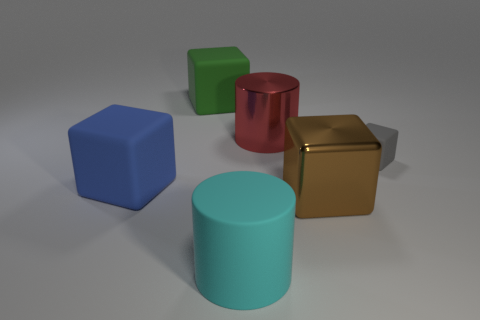What number of blocks are big cyan objects or small matte things?
Give a very brief answer. 1. The big shiny object in front of the rubber cube that is right of the big cyan cylinder is what color?
Offer a very short reply. Brown. There is a small thing; is it the same color as the large rubber object that is behind the gray matte thing?
Your response must be concise. No. The other thing that is made of the same material as the red thing is what size?
Keep it short and to the point. Large. Is the color of the metal block the same as the big shiny cylinder?
Offer a terse response. No. There is a cylinder in front of the rubber cube left of the green cube; are there any big blue matte objects that are in front of it?
Your response must be concise. No. How many brown shiny cubes are the same size as the brown object?
Your response must be concise. 0. Does the gray matte block that is in front of the large metallic cylinder have the same size as the cube behind the metal cylinder?
Your answer should be very brief. No. There is a rubber object that is both on the right side of the green rubber block and in front of the gray rubber object; what is its shape?
Your answer should be compact. Cylinder. Is there a large rubber object of the same color as the metal cube?
Provide a succinct answer. No. 